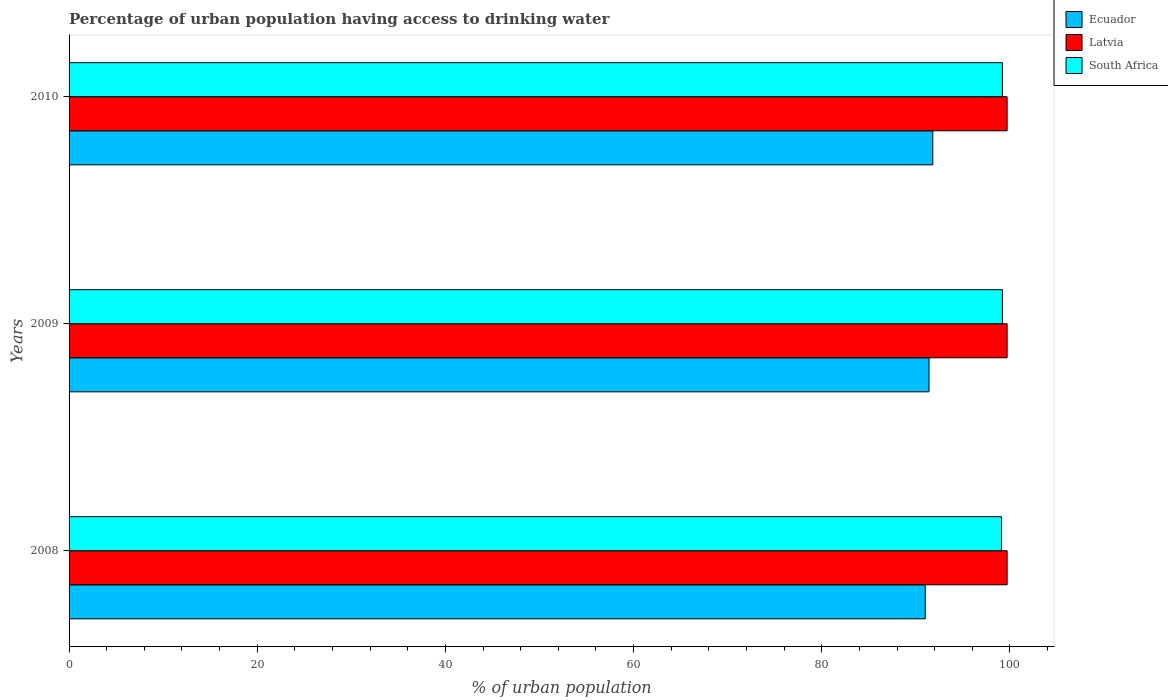Are the number of bars on each tick of the Y-axis equal?
Provide a succinct answer. Yes. How many bars are there on the 1st tick from the top?
Your answer should be very brief. 3. How many bars are there on the 1st tick from the bottom?
Give a very brief answer. 3. In how many cases, is the number of bars for a given year not equal to the number of legend labels?
Provide a succinct answer. 0. What is the percentage of urban population having access to drinking water in Ecuador in 2008?
Your answer should be very brief. 91. Across all years, what is the maximum percentage of urban population having access to drinking water in Latvia?
Your answer should be compact. 99.7. Across all years, what is the minimum percentage of urban population having access to drinking water in South Africa?
Your response must be concise. 99.1. In which year was the percentage of urban population having access to drinking water in South Africa minimum?
Make the answer very short. 2008. What is the total percentage of urban population having access to drinking water in Latvia in the graph?
Your answer should be very brief. 299.1. What is the difference between the percentage of urban population having access to drinking water in Ecuador in 2009 and the percentage of urban population having access to drinking water in Latvia in 2008?
Provide a succinct answer. -8.3. What is the average percentage of urban population having access to drinking water in Ecuador per year?
Offer a very short reply. 91.4. Is the difference between the percentage of urban population having access to drinking water in South Africa in 2008 and 2009 greater than the difference between the percentage of urban population having access to drinking water in Latvia in 2008 and 2009?
Your answer should be compact. No. What is the difference between the highest and the lowest percentage of urban population having access to drinking water in Latvia?
Ensure brevity in your answer.  0. In how many years, is the percentage of urban population having access to drinking water in Ecuador greater than the average percentage of urban population having access to drinking water in Ecuador taken over all years?
Give a very brief answer. 2. What does the 1st bar from the top in 2008 represents?
Offer a terse response. South Africa. What does the 1st bar from the bottom in 2009 represents?
Ensure brevity in your answer.  Ecuador. How many bars are there?
Offer a very short reply. 9. Are all the bars in the graph horizontal?
Provide a short and direct response. Yes. How many years are there in the graph?
Your response must be concise. 3. Are the values on the major ticks of X-axis written in scientific E-notation?
Your response must be concise. No. Does the graph contain any zero values?
Your answer should be compact. No. Does the graph contain grids?
Provide a short and direct response. No. Where does the legend appear in the graph?
Your answer should be compact. Top right. How many legend labels are there?
Provide a succinct answer. 3. What is the title of the graph?
Provide a short and direct response. Percentage of urban population having access to drinking water. Does "Guyana" appear as one of the legend labels in the graph?
Give a very brief answer. No. What is the label or title of the X-axis?
Ensure brevity in your answer.  % of urban population. What is the label or title of the Y-axis?
Offer a very short reply. Years. What is the % of urban population in Ecuador in 2008?
Your response must be concise. 91. What is the % of urban population in Latvia in 2008?
Provide a succinct answer. 99.7. What is the % of urban population in South Africa in 2008?
Ensure brevity in your answer.  99.1. What is the % of urban population in Ecuador in 2009?
Your answer should be very brief. 91.4. What is the % of urban population in Latvia in 2009?
Provide a succinct answer. 99.7. What is the % of urban population of South Africa in 2009?
Your response must be concise. 99.2. What is the % of urban population in Ecuador in 2010?
Give a very brief answer. 91.8. What is the % of urban population in Latvia in 2010?
Your answer should be very brief. 99.7. What is the % of urban population of South Africa in 2010?
Ensure brevity in your answer.  99.2. Across all years, what is the maximum % of urban population in Ecuador?
Make the answer very short. 91.8. Across all years, what is the maximum % of urban population of Latvia?
Your response must be concise. 99.7. Across all years, what is the maximum % of urban population of South Africa?
Make the answer very short. 99.2. Across all years, what is the minimum % of urban population of Ecuador?
Your answer should be compact. 91. Across all years, what is the minimum % of urban population of Latvia?
Keep it short and to the point. 99.7. Across all years, what is the minimum % of urban population of South Africa?
Your answer should be very brief. 99.1. What is the total % of urban population of Ecuador in the graph?
Give a very brief answer. 274.2. What is the total % of urban population in Latvia in the graph?
Ensure brevity in your answer.  299.1. What is the total % of urban population in South Africa in the graph?
Offer a terse response. 297.5. What is the difference between the % of urban population in South Africa in 2008 and that in 2009?
Provide a short and direct response. -0.1. What is the difference between the % of urban population in Latvia in 2008 and that in 2010?
Make the answer very short. 0. What is the difference between the % of urban population in South Africa in 2008 and that in 2010?
Keep it short and to the point. -0.1. What is the difference between the % of urban population of Latvia in 2009 and that in 2010?
Offer a very short reply. 0. What is the difference between the % of urban population of South Africa in 2009 and that in 2010?
Keep it short and to the point. 0. What is the difference between the % of urban population of Ecuador in 2008 and the % of urban population of Latvia in 2009?
Ensure brevity in your answer.  -8.7. What is the difference between the % of urban population in Ecuador in 2008 and the % of urban population in South Africa in 2009?
Your answer should be very brief. -8.2. What is the difference between the % of urban population of Ecuador in 2008 and the % of urban population of Latvia in 2010?
Provide a succinct answer. -8.7. What is the difference between the % of urban population of Ecuador in 2008 and the % of urban population of South Africa in 2010?
Provide a short and direct response. -8.2. What is the difference between the % of urban population in Ecuador in 2009 and the % of urban population in South Africa in 2010?
Your response must be concise. -7.8. What is the average % of urban population of Ecuador per year?
Keep it short and to the point. 91.4. What is the average % of urban population in Latvia per year?
Keep it short and to the point. 99.7. What is the average % of urban population of South Africa per year?
Provide a succinct answer. 99.17. In the year 2008, what is the difference between the % of urban population in Ecuador and % of urban population in South Africa?
Your response must be concise. -8.1. In the year 2009, what is the difference between the % of urban population of Ecuador and % of urban population of South Africa?
Make the answer very short. -7.8. In the year 2009, what is the difference between the % of urban population in Latvia and % of urban population in South Africa?
Your answer should be compact. 0.5. What is the ratio of the % of urban population of Ecuador in 2008 to that in 2009?
Your answer should be compact. 1. What is the ratio of the % of urban population of South Africa in 2008 to that in 2009?
Offer a very short reply. 1. What is the ratio of the % of urban population of South Africa in 2008 to that in 2010?
Offer a very short reply. 1. What is the ratio of the % of urban population in Latvia in 2009 to that in 2010?
Your answer should be compact. 1. What is the ratio of the % of urban population in South Africa in 2009 to that in 2010?
Your answer should be very brief. 1. What is the difference between the highest and the second highest % of urban population of Ecuador?
Make the answer very short. 0.4. What is the difference between the highest and the second highest % of urban population in Latvia?
Your response must be concise. 0. What is the difference between the highest and the second highest % of urban population in South Africa?
Make the answer very short. 0. What is the difference between the highest and the lowest % of urban population in Ecuador?
Offer a very short reply. 0.8. What is the difference between the highest and the lowest % of urban population of South Africa?
Offer a terse response. 0.1. 